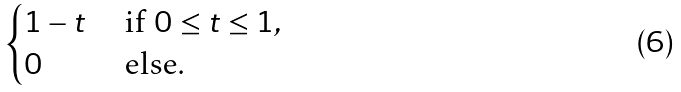Convert formula to latex. <formula><loc_0><loc_0><loc_500><loc_500>\begin{cases} 1 - t & \text { if } 0 \leq t \leq 1 , \\ 0 & \text { else} . \end{cases}</formula> 